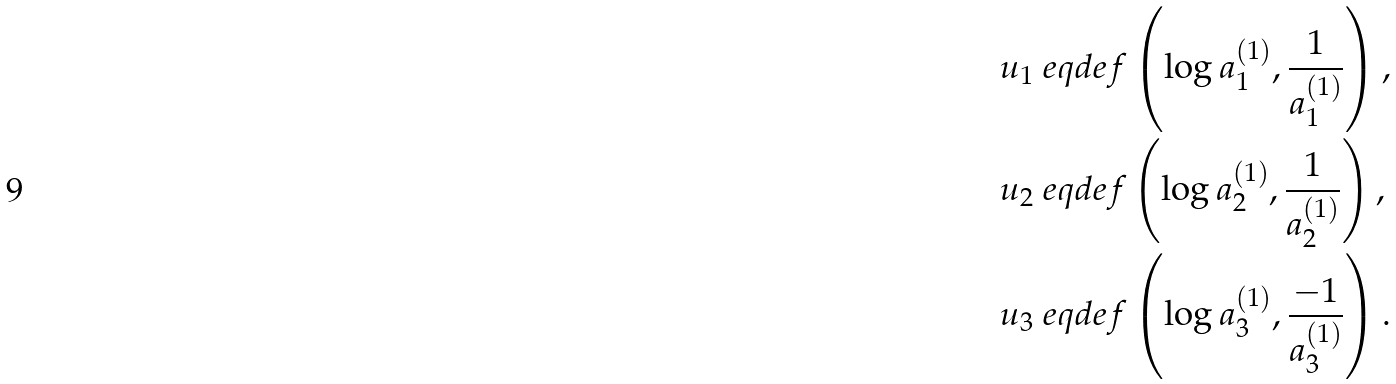Convert formula to latex. <formula><loc_0><loc_0><loc_500><loc_500>u _ { 1 } & \ e q d e f \left ( \log a _ { 1 } ^ { ( 1 ) } , \frac { 1 } { a _ { 1 } ^ { ( 1 ) } } \right ) , \\ u _ { 2 } & \ e q d e f \left ( \log a _ { 2 } ^ { ( 1 ) } , \frac { 1 } { a _ { 2 } ^ { ( 1 ) } } \right ) , \\ u _ { 3 } & \ e q d e f \left ( \log a _ { 3 } ^ { ( 1 ) } , \frac { - 1 } { a _ { 3 } ^ { ( 1 ) } } \right ) .</formula> 